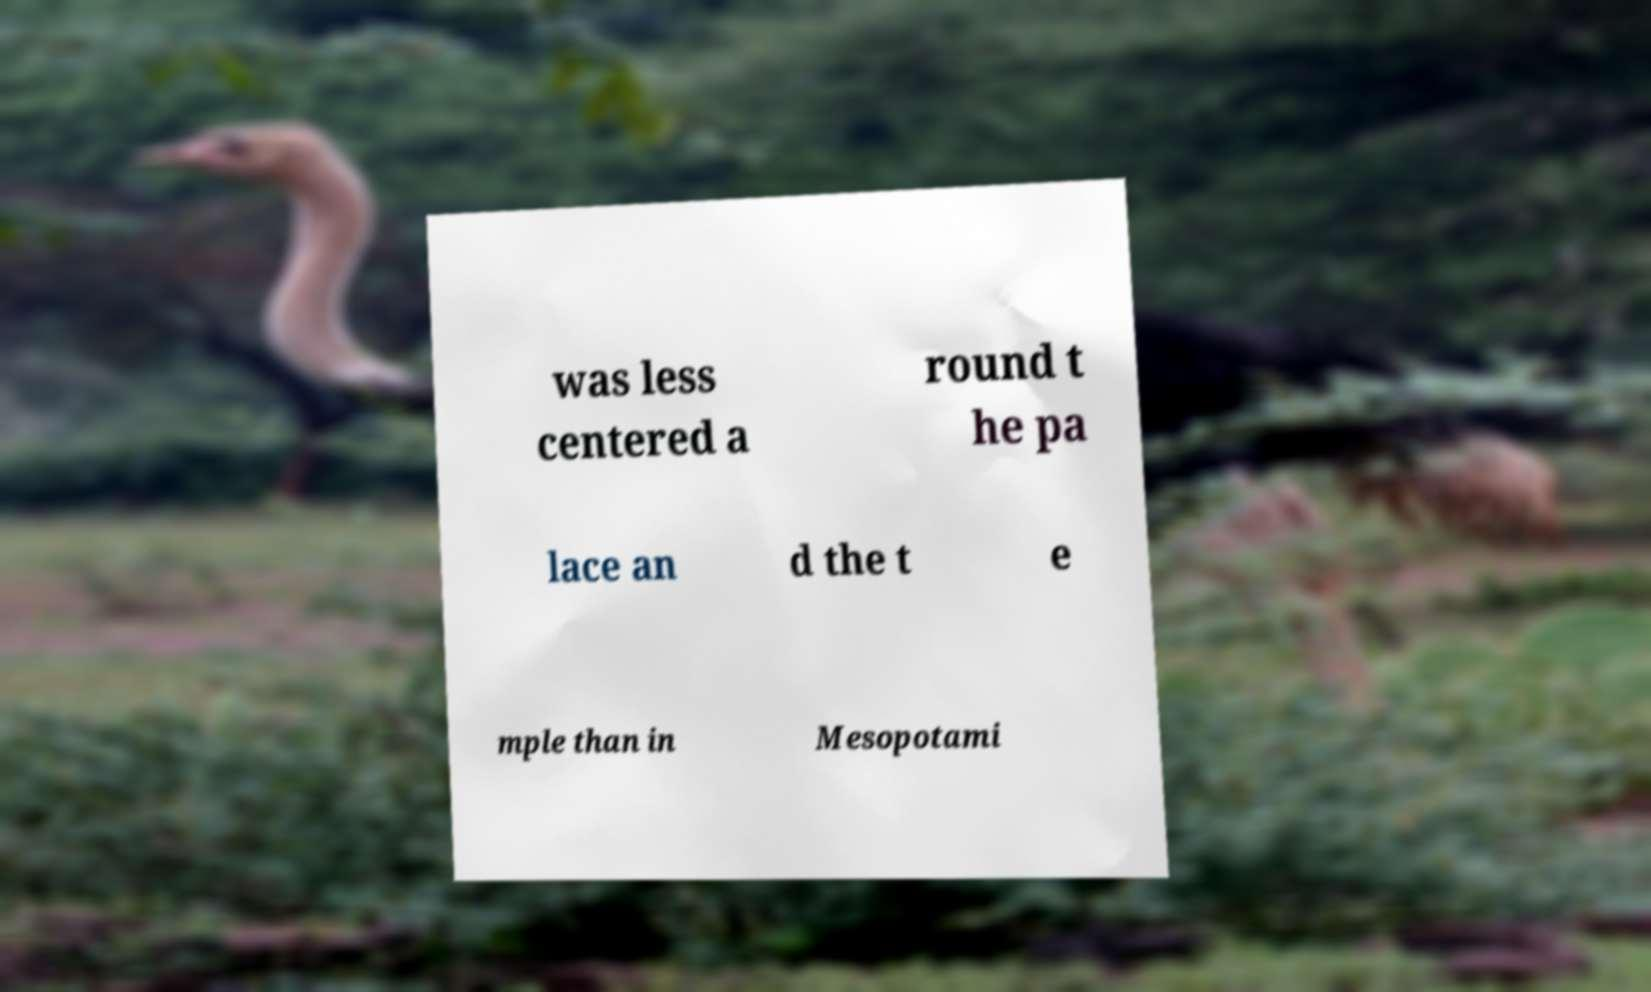For documentation purposes, I need the text within this image transcribed. Could you provide that? was less centered a round t he pa lace an d the t e mple than in Mesopotami 